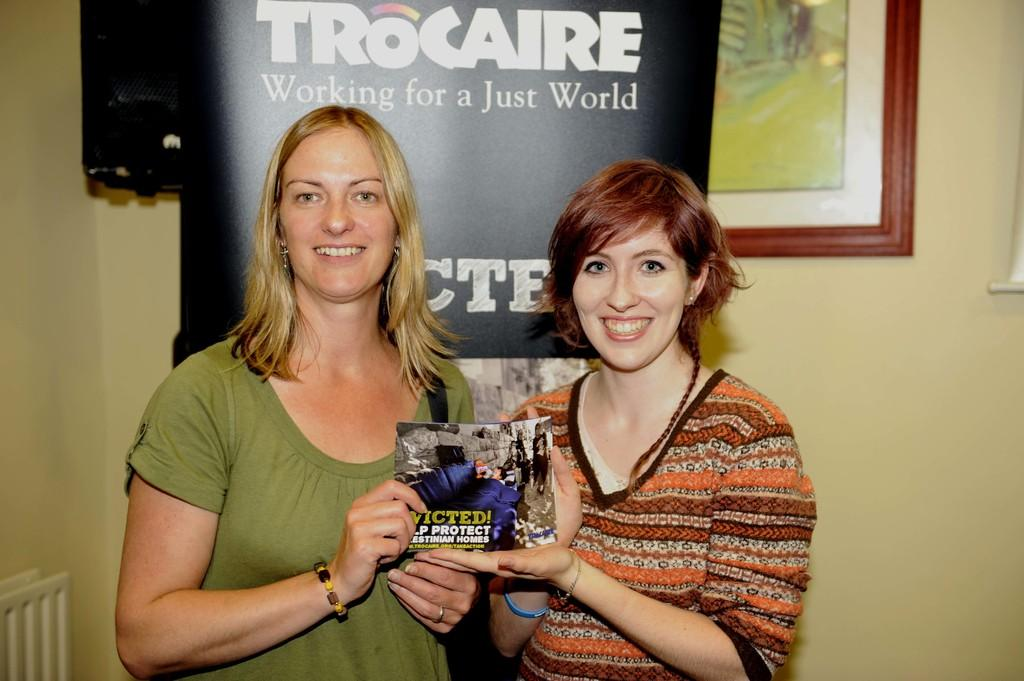How many women are in the image? There are two women in the image. What are the women doing in the image? The women are smiling and holding a book with their hands. What can be seen in the background of the image? There is a wall, a banner, and a frame in the background of the image. How many kittens are sitting on the book in the image? There are no kittens present in the image. What type of knife is being used by one of the women in the image? There is no knife visible in the image; the women are holding a book with their hands. 